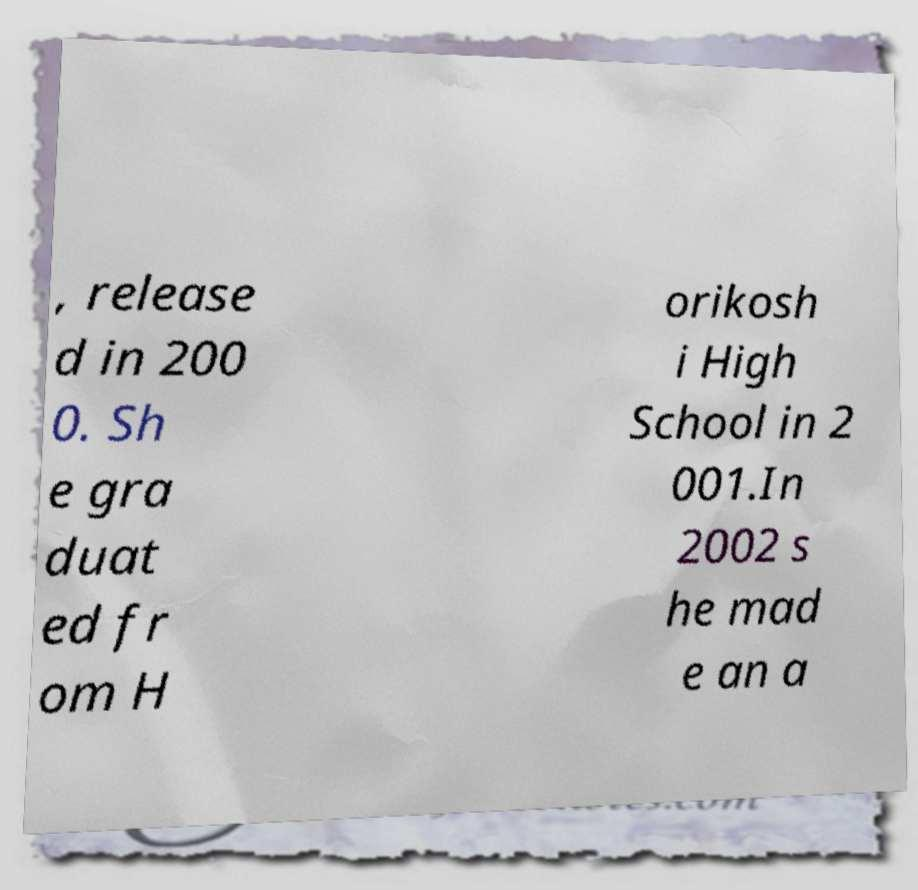Could you extract and type out the text from this image? , release d in 200 0. Sh e gra duat ed fr om H orikosh i High School in 2 001.In 2002 s he mad e an a 